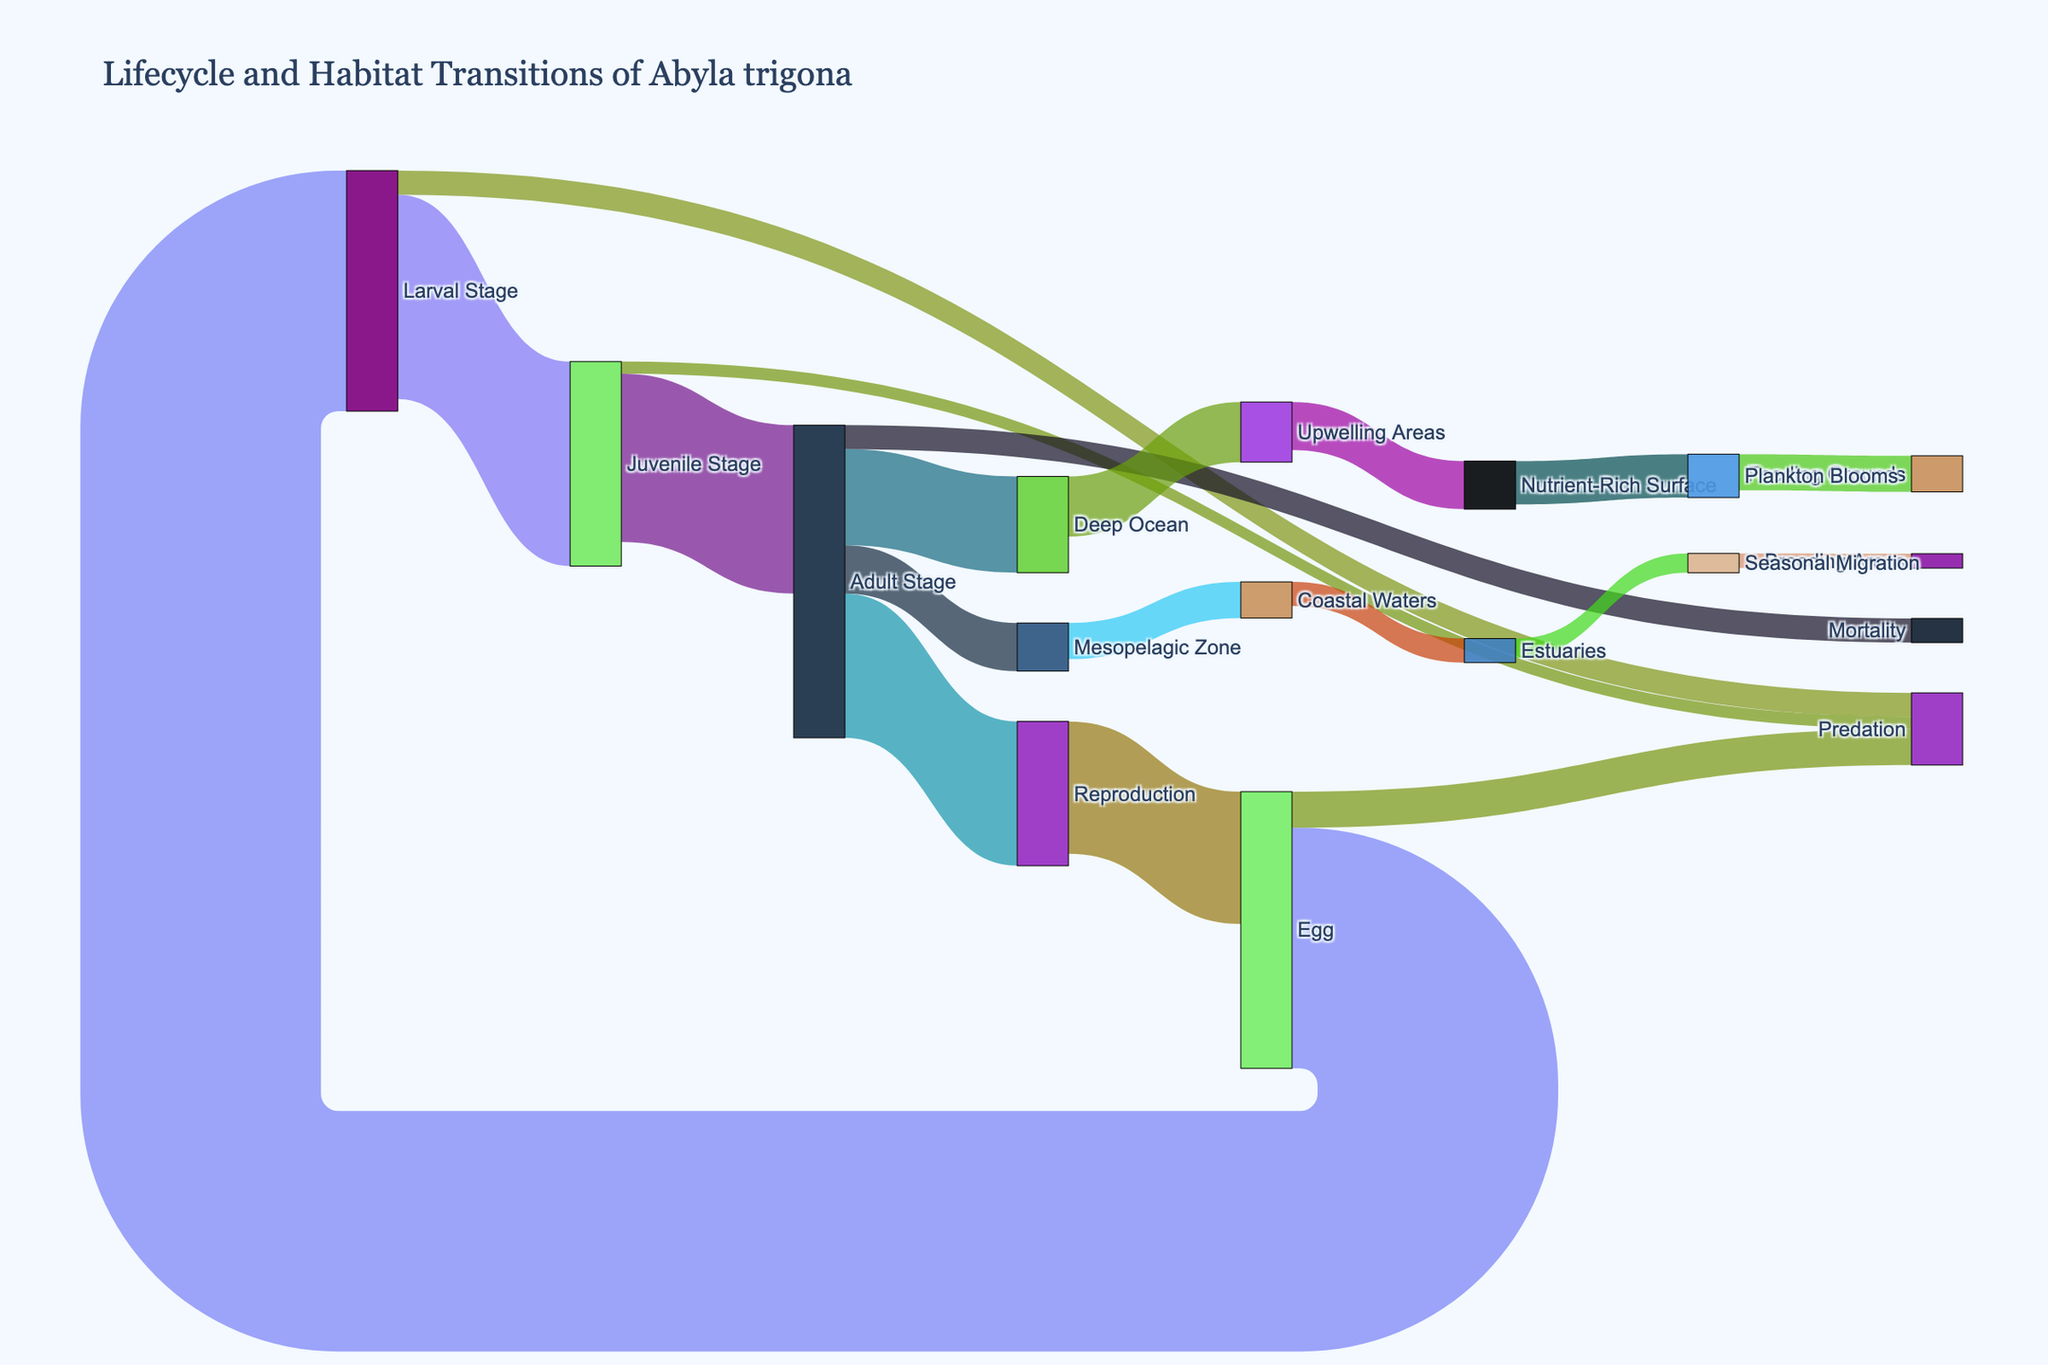What is the title of the Sankey diagram? The title is usually displayed at the top of the figure. It gives a summary of what the diagram is about.
Answer: Lifecycle and Habitat Transitions of Abyla trigona How many lifecycle stages does the Abyla trigona go through according to the diagram? Count the number of distinct lifecycle stages shown in the figure: Egg, Larval Stage, Juvenile Stage, Adult Stage, and Reproduction.
Answer: 5 What is the highest value of transition between stages, and between which stages does it occur? Look for the largest value associated with arrows connecting different stages. The largest value is 100 between Egg and Larval Stage.
Answer: 100, Egg to Larval Stage How many organisms reach the Deep Ocean habitat in the Adult Stage? Follow the arrow labeled 'Adult Stage' to 'Deep Ocean' and note the value indicated on the arrow.
Answer: 40 Compare the value transitioning from Adult Stage to Deep Ocean and from Adult Stage to Mesopelagic Zone. Which is greater? Identify the values related to these two transitions on the diagram and compare them: 40 (Deep Ocean) vs. 20 (Mesopelagic Zone).
Answer: 40 (Deep Ocean) is greater What is the total number of organisms that transition to predation across all lifecycle stages? Sum the values of transitions that lead to Predation: Egg (15) + Larval Stage (10) + Juvenile Stage (5).
Answer: 30 What percentage of organisms from the Egg stage transition to the Larval Stage compared to those subject to predation? Calculate the percentage using the values from Egg to Larval Stage (100) and Egg to Predation (15). (100 / (100 + 15)) * 100%.
Answer: 87% Which habitat transitioning from Upwelling Areas has the highest transition value, and what is it? Check the values for transitions from Upwelling Areas and identify the highest: Upwelling Areas to Nutrient-Rich Surface (20).
Answer: Nutrient-Rich Surface, 20 